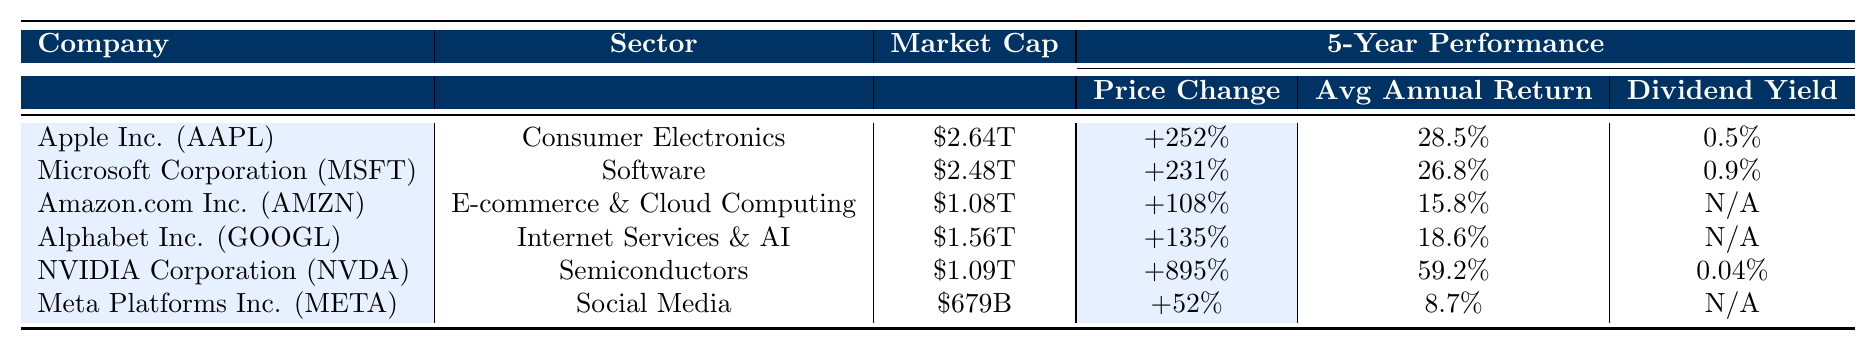What is the market cap of NVIDIA Corporation? The table shows the market cap of NVIDIA Corporation (NVDA) as $1.09T.
Answer: $1.09T Which company has the highest dividend yield? Looking at the table, Apple Inc. has a dividend yield of 0.5%, which is higher than other companies listed.
Answer: Apple Inc. (AAPL) What is the price change percentage for Amazon.com Inc.? The table indicates that Amazon.com Inc. (AMZN) has a price change of +108% over the past 5 years.
Answer: +108% How does Alphabet Inc.'s average annual return compare to Meta Platforms Inc.'s? Alphabet Inc. has an average annual return of 18.6% while Meta Platforms Inc. has 8.7%. Alphabet's return is higher.
Answer: Higher Which company had the least price change over the past 5 years? The table shows that Meta Platforms Inc. had the least price change at +52%.
Answer: Meta Platforms Inc. (META) What is the combined average annual return of Apple Inc. and Microsoft Corporation? The average annual return for Apple Inc. is 28.5% and for Microsoft Corporation is 26.8%. Adding these gives 28.5% + 26.8% = 55.3%. To find the average, divide by 2: 55.3% / 2 = 27.65%.
Answer: 27.65% Is the dividend yield for Amazon.com Inc. available in the table? The table indicates that Amazon.com Inc. does not have a dividend yield listed, marked as N/A.
Answer: No Which company has the highest market cap? According to the table, Apple Inc. has the highest market cap at $2.64T, compared to others listed.
Answer: Apple Inc. (AAPL) What would be the difference in price change percentages between NVIDIA and Meta Platforms? NVIDIA's price change is +895% and Meta Platforms' is +52%. The difference is 895% - 52% = 843%.
Answer: 843% Which sector does Microsoft Corporation belong to? The table lists Microsoft Corporation under the Software sector.
Answer: Software If you invest $1000 in Apple Inc., how much would you gain based on the average annual return? With an average annual return of 28.5%, after 5 years, the total value would be $1000 * (1 + 0.285)^5 = approximately $3677.06. The gain would be $3677.06 - $1000 = $2677.06.
Answer: $2677.06 